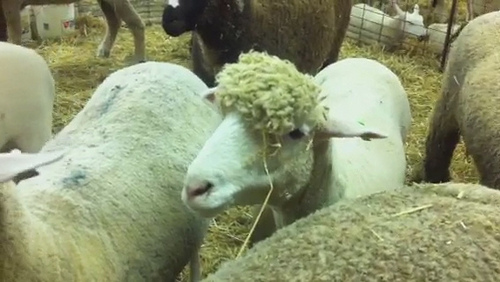You stumble upon a journal written by one of the sheep, detailing a day's events. What might an entry from the journal say? Dear Journal, Today was a lovely day in the pen. I spent the morning basking in the sunshine while munching on some fresh hay. The new batch that the farmers brought in is simply delightful. Around noon, we all gathered near the fence to see the young lambs playing; their antics always bring a smile. In the afternoon, I had a brief nap and chatted with Woolly about the upcoming shearing season. The evening was calm, with the warm glow of the sunset casting long shadows. Truly, another perfect day on the farm. - Fluffy 